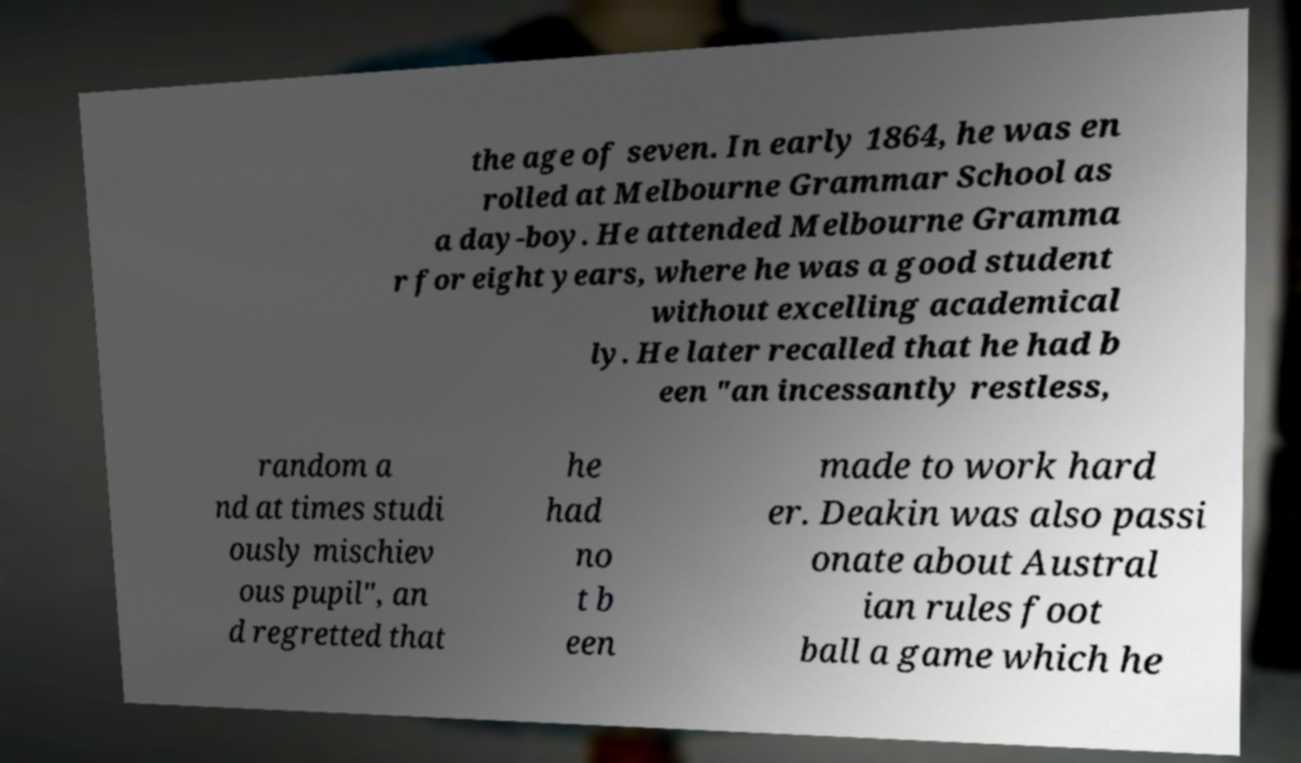Can you read and provide the text displayed in the image?This photo seems to have some interesting text. Can you extract and type it out for me? the age of seven. In early 1864, he was en rolled at Melbourne Grammar School as a day-boy. He attended Melbourne Gramma r for eight years, where he was a good student without excelling academical ly. He later recalled that he had b een "an incessantly restless, random a nd at times studi ously mischiev ous pupil", an d regretted that he had no t b een made to work hard er. Deakin was also passi onate about Austral ian rules foot ball a game which he 